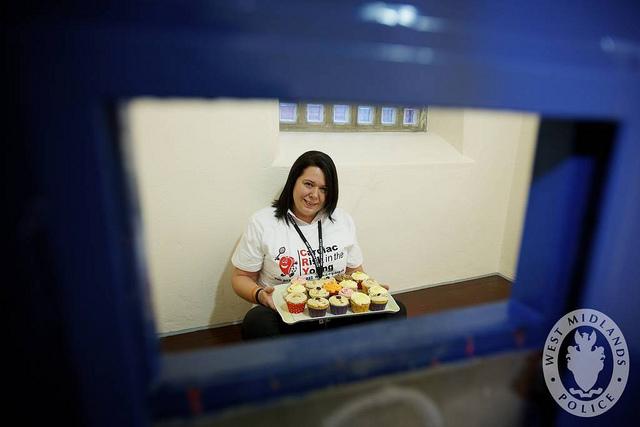Who wants her food?
Concise answer only. Police. What do you think was used to represent the gravel under the cake?
Keep it brief. Oreos. What is the little girl doing?
Concise answer only. Serving cupcakes. What is the woman selling?
Answer briefly. Cupcakes. What is this woman doing?
Quick response, please. Holding cupcakes. Is the woman a waitress?
Quick response, please. No. What are the decorations on the girl's dress?
Short answer required. Words. Is this on the street?
Give a very brief answer. No. Does the girl look guilty?
Write a very short answer. No. What is the white object the woman is grasping?
Keep it brief. Tray. What is she holding?
Concise answer only. Cupcakes. What are the people in the background doing?
Write a very short answer. Holding tray. Is it a man or woman on the television?
Concise answer only. Woman. What website is stamped on this photo?
Quick response, please. West midlands police. What type of treat is in the person's hand?
Short answer required. Cupcakes. Is the food cooked?
Be succinct. Yes. Is it during the Christmas season?
Short answer required. No. What city was this taken?
Short answer required. West midlands. What is on the necklace?
Keep it brief. Tag. Is this a window?
Write a very short answer. Yes. What is the name of the police department?
Give a very brief answer. West midlands. What is the girls activity?
Keep it brief. Baking. What cookies are on the table?
Keep it brief. Cupcakes. What kind of food is the lady carrying?
Short answer required. Cupcakes. What color is the cupcake?
Be succinct. White. What is turned on?
Concise answer only. Light. What jewelry is this woman wearing?
Give a very brief answer. Bracelet. What is the blurred object?
Write a very short answer. Door. What shape is the sign?
Keep it brief. Oval. What is under her right hand?
Concise answer only. Tray. What is the number on the shirt?
Write a very short answer. 1. Is this person a woman?
Keep it brief. Yes. What is the woman holding in her hand?
Keep it brief. Cupcakes. 